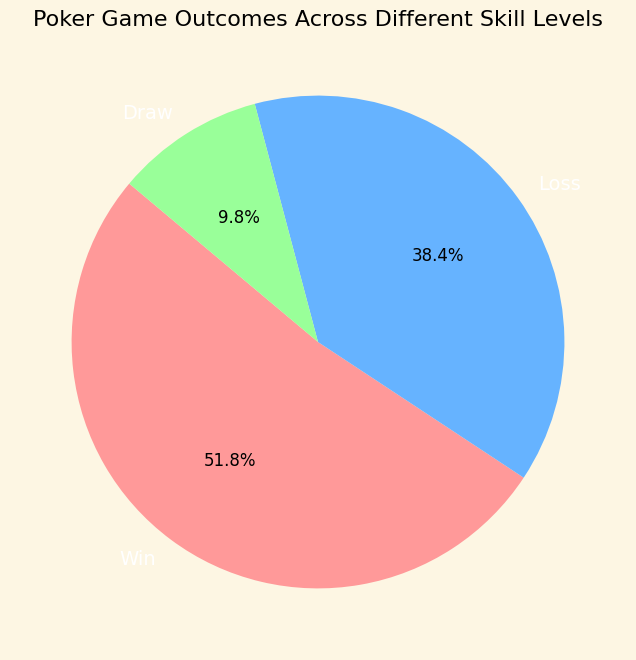What percentage of the game outcomes resulted in a win? To determine this, sum the values of Wins across all skill levels and then divide by the total number of all outcomes (Win, Loss, Draw). This requires calculating the sum for wins, losses, and draws, and then finding the proportion that wins constitute. Total wins = 425, Total outcomes = 850. The percentage of wins is (425/850) * 100.
Answer: 50% Which result was the least common in the pie chart? From the pie chart, observe the size of each segment. The segment representing Draws is the smallest, indicating it is the least common outcome.
Answer: Draw Are there more wins or losses? Compare the sizes of segments labeled "Win" and "Loss". The segment representing Wins is slightly larger than that for Losses.
Answer: Wins What is the combined percentage of losses and draws? Sum the percentages of Losses and Draws shown on the pie chart. Losses = 41.2% and Draws = 11.8%. Combined percentage = 41.2% + 11.8%.
Answer: 53% Which outcome has the largest segment in the pie chart? Look for the outcome with the largest segment in the pie chart. The "Win" segment is the largest.
Answer: Win By how much do wins exceed draws? Calculate the difference between the percentages of Wins and Draws. Wins = 50%, Draws = 11.8%. Difference = 50% - 11.8%.
Answer: 38.2% What fraction of total game outcomes resulted in a draw? Determine the draw percentage from the pie chart (11.8%) and convert that into a fraction of the total. 11.8% as a fraction of the total number of outcomes is 60/500 or simplified to 3/25.
Answer: 3/25 How do the win percentages compare between Beginner and Advanced skill levels? For Beginner and Advanced skill levels, compare their win percentages from the dataset. Beginner = (50+45)/(50+80+10+45+85+10) ≈ 38.3%, Advanced = (90+95)/(90+30+10+95+25+10) ≈ 67.3%.
Answer: Advanced > Beginner 